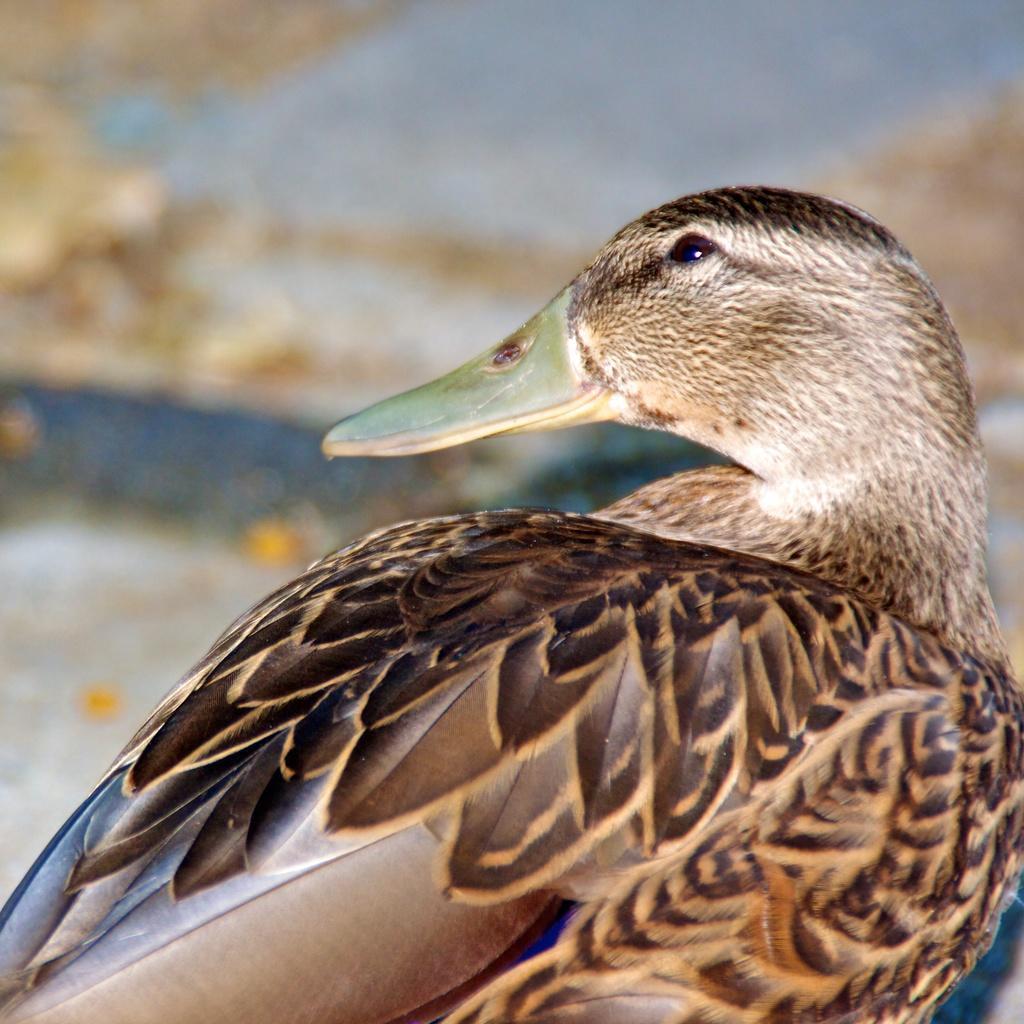Please provide a concise description of this image. In the picture I can see a bird. The background of the image is blurred. 